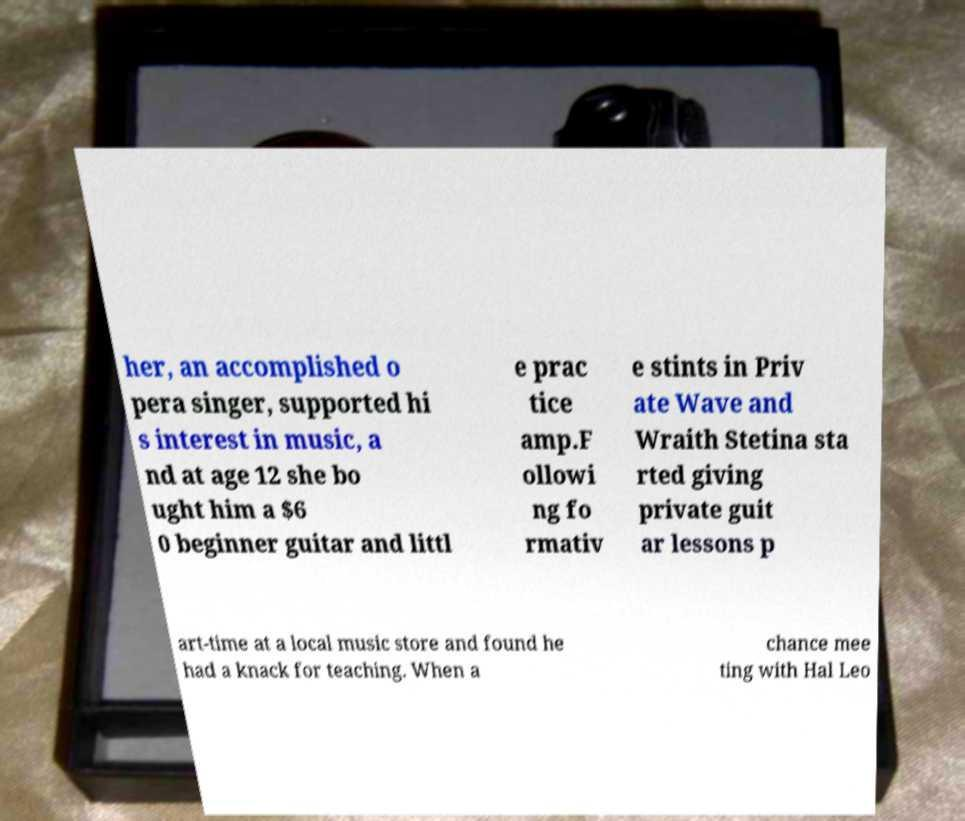There's text embedded in this image that I need extracted. Can you transcribe it verbatim? her, an accomplished o pera singer, supported hi s interest in music, a nd at age 12 she bo ught him a $6 0 beginner guitar and littl e prac tice amp.F ollowi ng fo rmativ e stints in Priv ate Wave and Wraith Stetina sta rted giving private guit ar lessons p art-time at a local music store and found he had a knack for teaching. When a chance mee ting with Hal Leo 